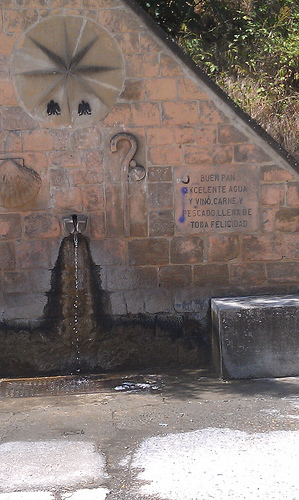<image>
Can you confirm if the water is on the road? Yes. Looking at the image, I can see the water is positioned on top of the road, with the road providing support. 